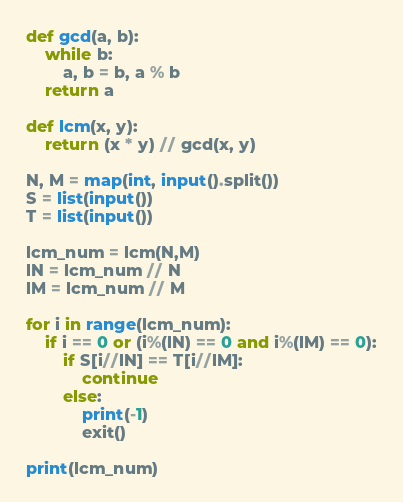Convert code to text. <code><loc_0><loc_0><loc_500><loc_500><_Python_>def gcd(a, b):
	while b:
		a, b = b, a % b
	return a

def lcm(x, y):
    return (x * y) // gcd(x, y)

N, M = map(int, input().split())
S = list(input())
T = list(input())

lcm_num = lcm(N,M)
lN = lcm_num // N
lM = lcm_num // M

for i in range(lcm_num):
    if i == 0 or (i%(lN) == 0 and i%(lM) == 0):
        if S[i//lN] == T[i//lM]:
            continue
        else:
            print(-1)
            exit()

print(lcm_num)
</code> 